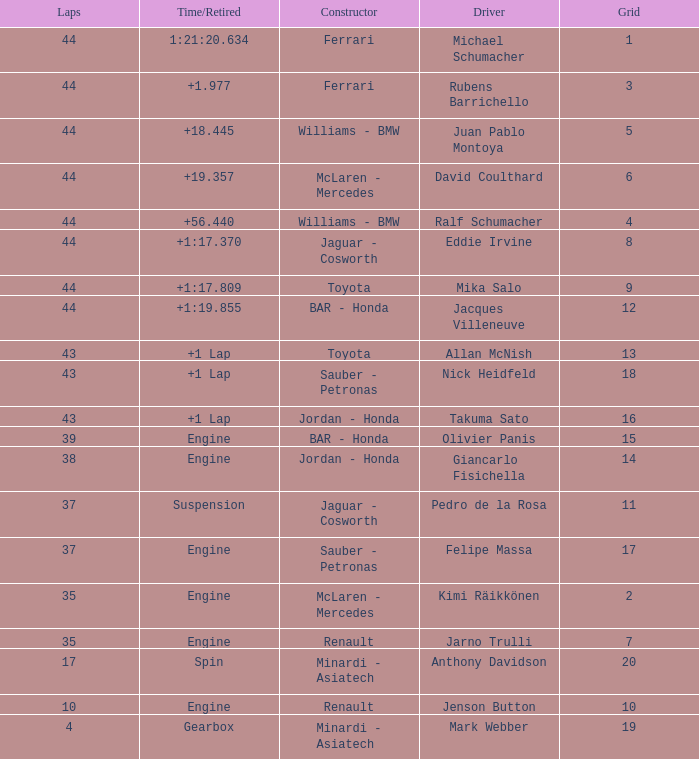What was the time of the driver on grid 3? 1.977. 